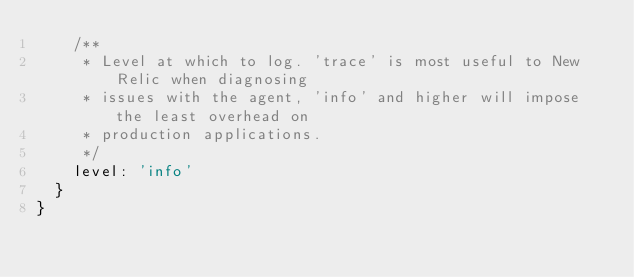<code> <loc_0><loc_0><loc_500><loc_500><_JavaScript_>    /**
     * Level at which to log. 'trace' is most useful to New Relic when diagnosing
     * issues with the agent, 'info' and higher will impose the least overhead on
     * production applications.
     */
    level: 'info'
  }
}
</code> 